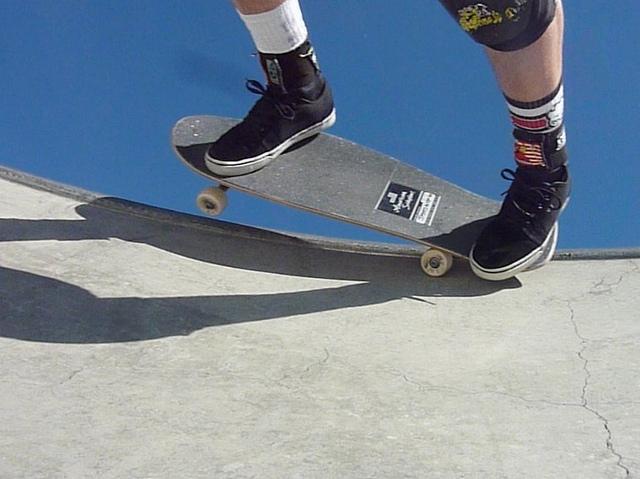What kind of traction do the wheels have on this skateboard in the photo?
Write a very short answer. Little. What color are the socks?
Short answer required. White. Is this person skateboarding at a skate park?
Write a very short answer. Yes. 